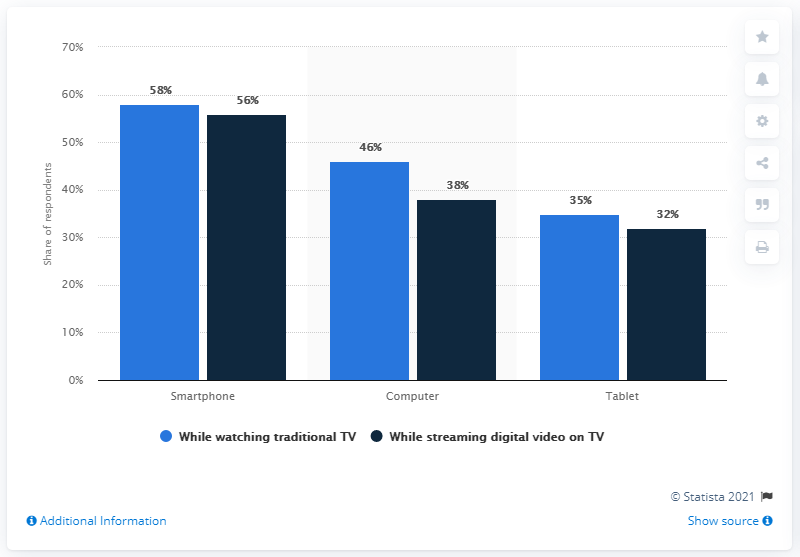Identify some key points in this picture. The tablet has a difference of 3% compared to the previous model. The graph displays the indicated devices [Smartphone, Computer, Tablet] and their corresponding percentages. 